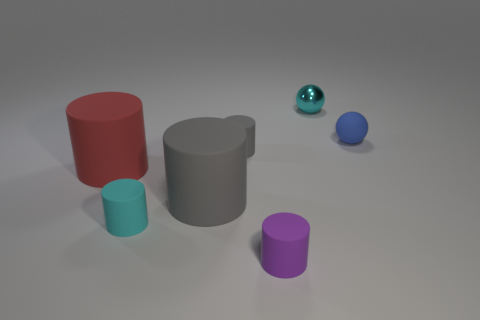There is a cyan metallic object; does it have the same shape as the matte object that is behind the small gray object?
Offer a terse response. Yes. What is the material of the cyan object left of the rubber cylinder that is in front of the cyan thing that is in front of the red matte object?
Provide a short and direct response. Rubber. What number of large things are either cyan metal things or purple matte cylinders?
Provide a succinct answer. 0. What number of other things are the same size as the blue thing?
Your answer should be very brief. 4. Is the shape of the tiny cyan object on the right side of the cyan cylinder the same as  the purple thing?
Make the answer very short. No. There is a rubber object that is the same shape as the small cyan shiny thing; what color is it?
Provide a short and direct response. Blue. Are there the same number of balls that are left of the cyan shiny object and brown cylinders?
Your answer should be very brief. Yes. How many tiny cyan things are left of the tiny metallic sphere and behind the red thing?
Make the answer very short. 0. What size is the red object that is the same shape as the small purple thing?
Keep it short and to the point. Large. What number of small gray blocks have the same material as the blue object?
Ensure brevity in your answer.  0. 